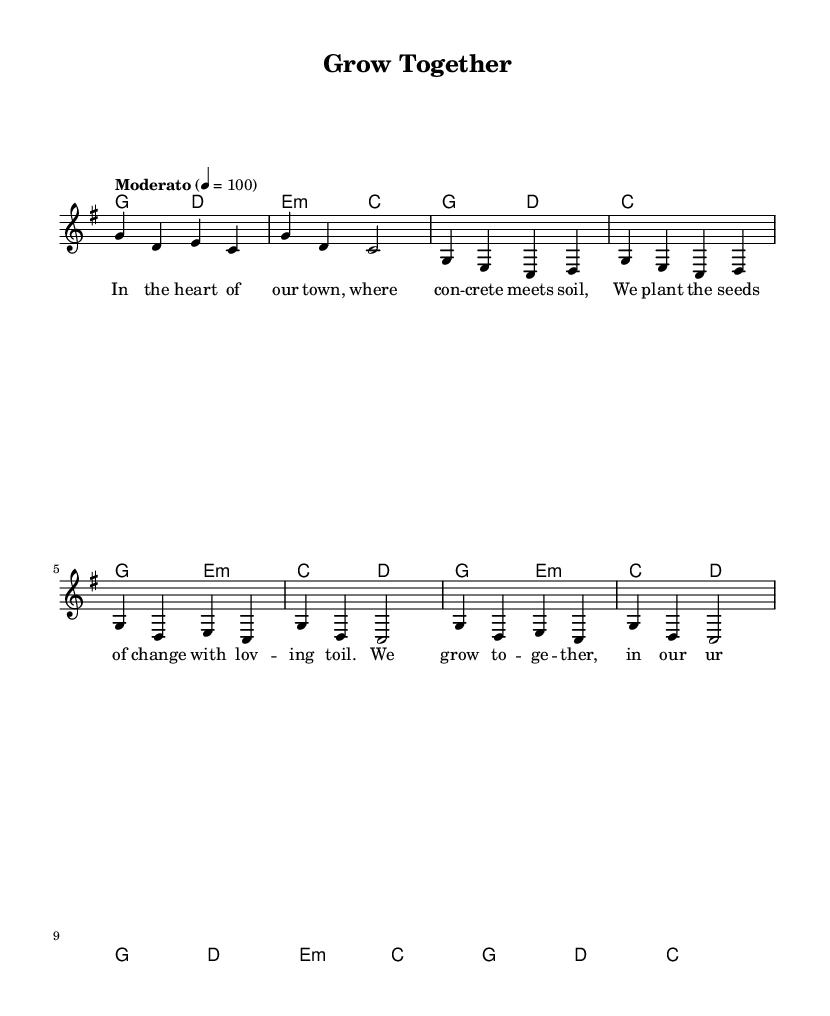What is the key signature of this music? The key signature is G major, which has one sharp (F#). This can be determined by looking for any sharps or flats indicated at the beginning of the staff.
Answer: G major What is the time signature of this music? The time signature is 4/4, which can be observed on the left side of the staff. It indicates that there are four beats per measure, and a quarter note receives one beat.
Answer: 4/4 What is the tempo marking for this piece? The tempo marking is Moderato, which indicates a moderate speed for the piece. This is typically placed above the staff near the beginning of the sheet music.
Answer: Moderato How many measures are in the chorus section? There are four measures in the chorus section. By counting the measures in the chorus lyrics and noting the corresponding melody and harmonies, we see the chorus spans four measures.
Answer: Four What is the dynamic marking at the beginning of the score? The dynamic marking at the beginning of the score is not explicitly stated in the provided data. Since no dynamics are specified, it can be assumed to start at a neutral dynamic.
Answer: None specified What is the main theme of the lyrics? The main theme of the lyrics focuses on community and growth in an urban environment, as illustrated in phrases like "We grow together" and references to planting seeds and building community.
Answer: Community growth What type of song is "Grow Together"? "Grow Together" is classified as a folk song, which typically includes themes related to community, nature, and shared experiences, often conveyed through simple melodies and heartfelt lyrics.
Answer: Folk song 